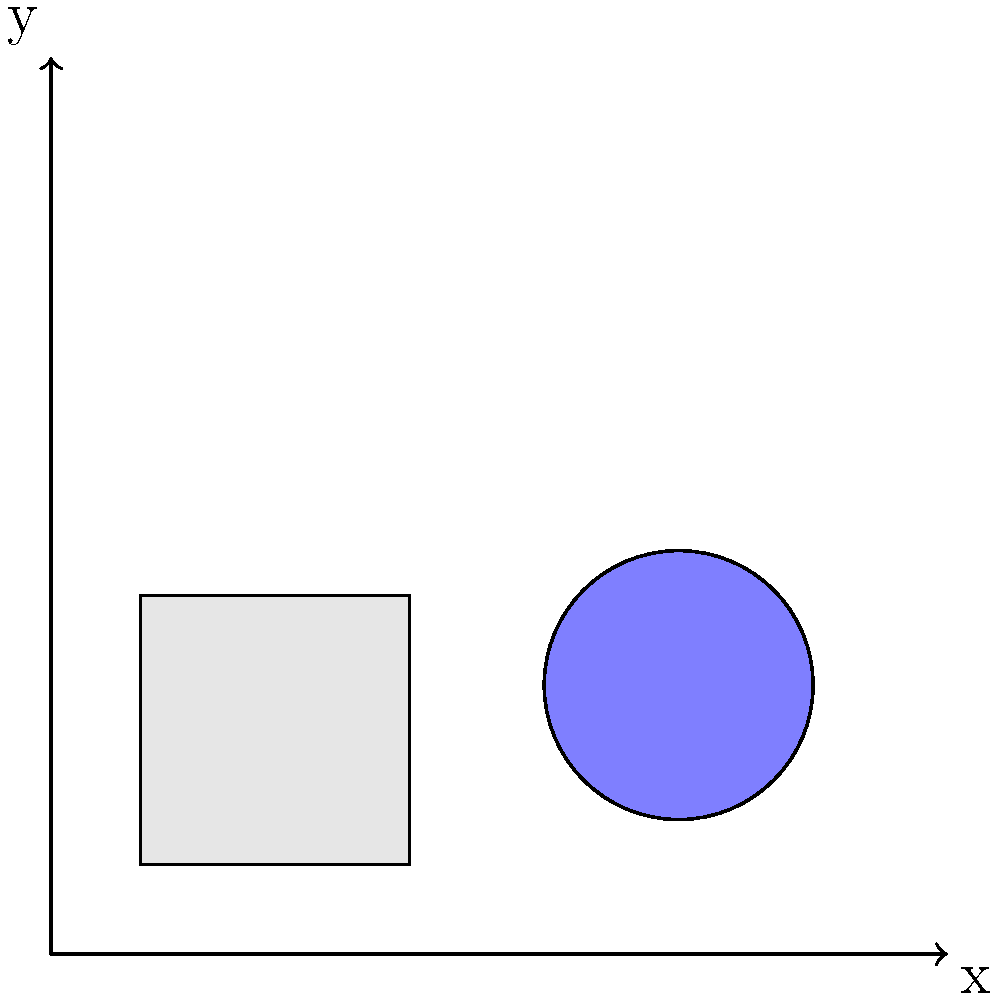In the given UI layout, what are the coordinates of the center point of the circular icon element? To determine the coordinates of the center point of the circular icon element, we need to follow these steps:

1. Observe the coordinate system:
   The diagram shows a 2D coordinate system with x and y axes.

2. Identify the circular icon:
   There's a light blue circular shape in the layout, labeled "Icon".

3. Locate the center point:
   The center of the circle is marked with a red dot.

4. Read the coordinates:
   Next to the red dot for the icon's center, we can see the coordinates labeled as (70,30).

5. Interpret the coordinates:
   - The first number (70) represents the x-coordinate.
   - The second number (30) represents the y-coordinate.

6. Verify the position:
   The point (70,30) is indeed at the center of the circular icon, approximately 70 units to the right of the origin and 30 units up from the origin.

Therefore, the coordinates of the center point of the circular icon element are (70,30).
Answer: (70,30) 